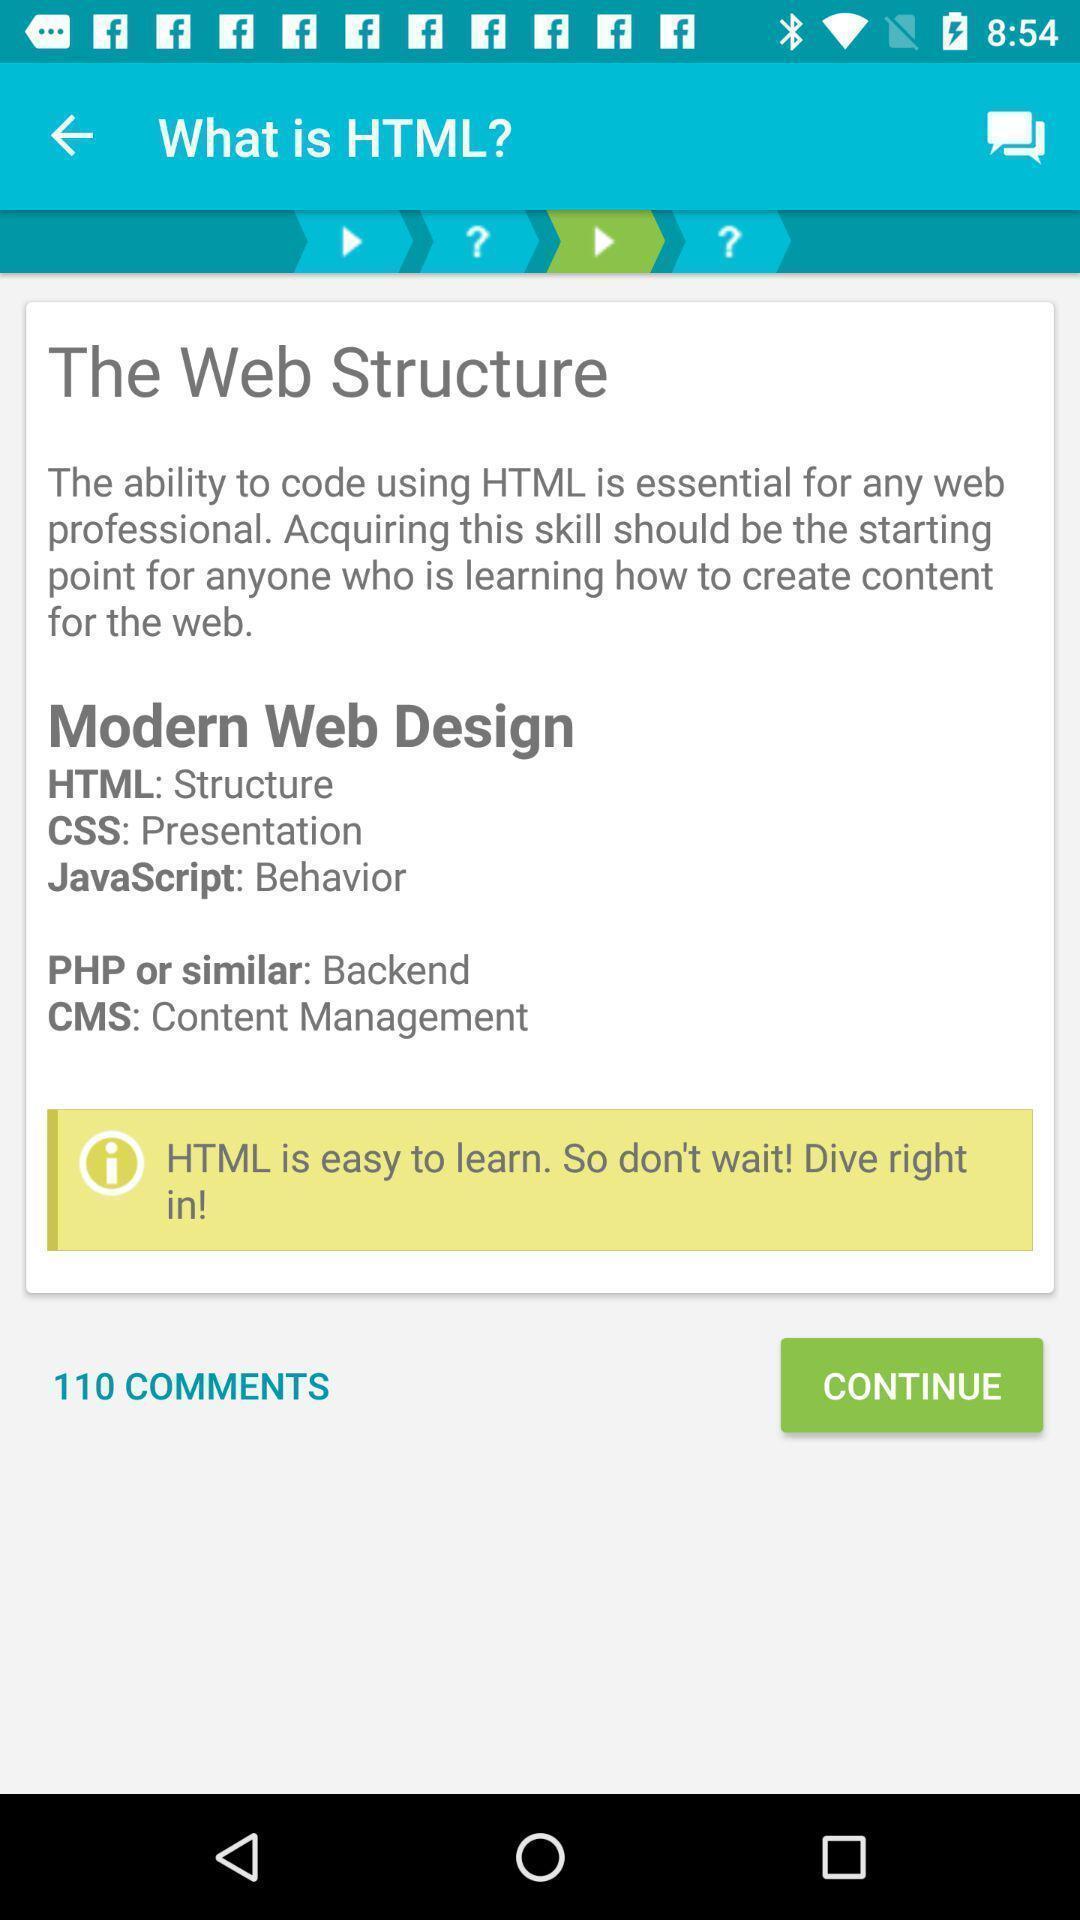Please provide a description for this image. Screen shows about computer language app. 